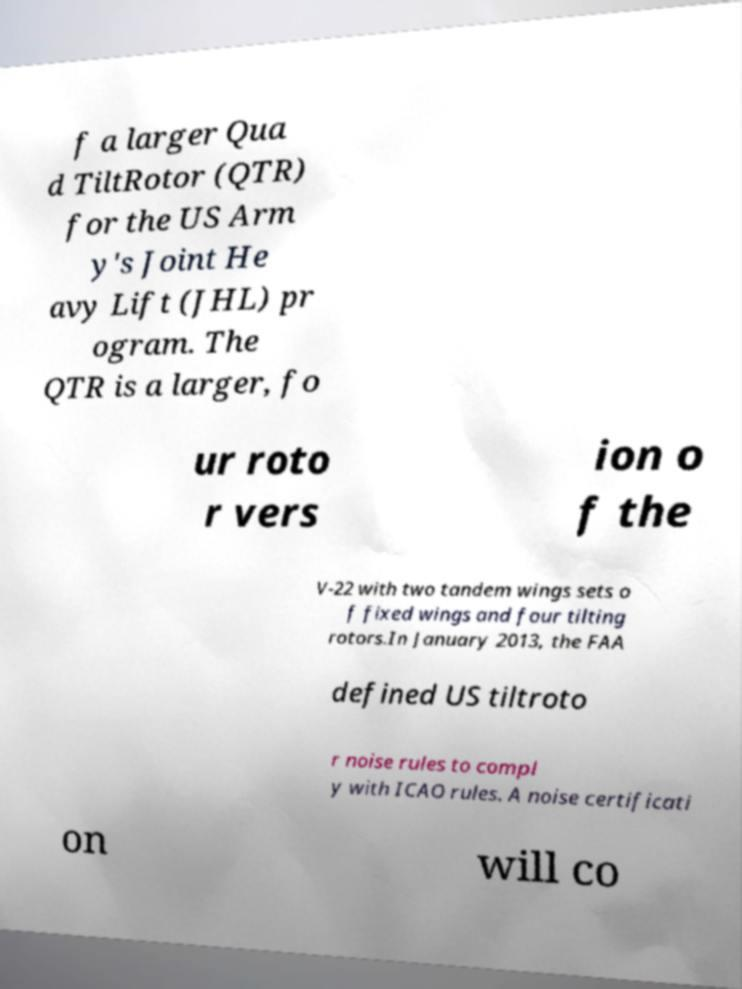Can you accurately transcribe the text from the provided image for me? f a larger Qua d TiltRotor (QTR) for the US Arm y's Joint He avy Lift (JHL) pr ogram. The QTR is a larger, fo ur roto r vers ion o f the V-22 with two tandem wings sets o f fixed wings and four tilting rotors.In January 2013, the FAA defined US tiltroto r noise rules to compl y with ICAO rules. A noise certificati on will co 